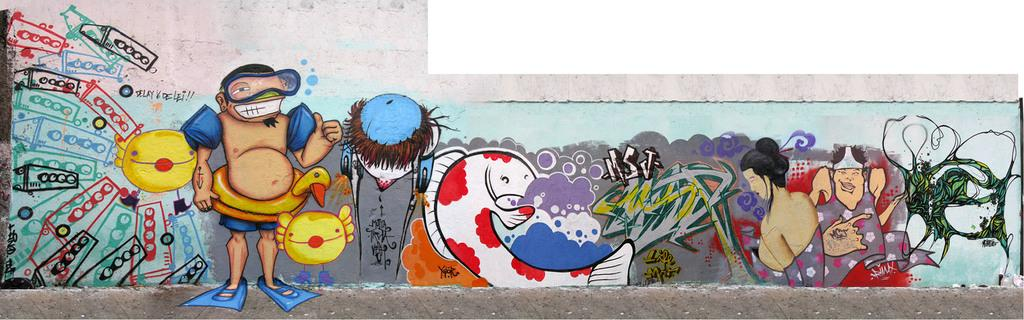What is the main subject of the wall painting in the image? The wall painting depicts people. Are there any other elements in the wall painting besides the people? Yes, the wall painting includes various objects. What colors are used in the wall painting? The colors used in the wall painting are red, yellow, black, white, green, and purple. How many brothers are depicted in the wall painting? There is no mention of brothers in the image or the wall painting; it only depicts people and objects. 